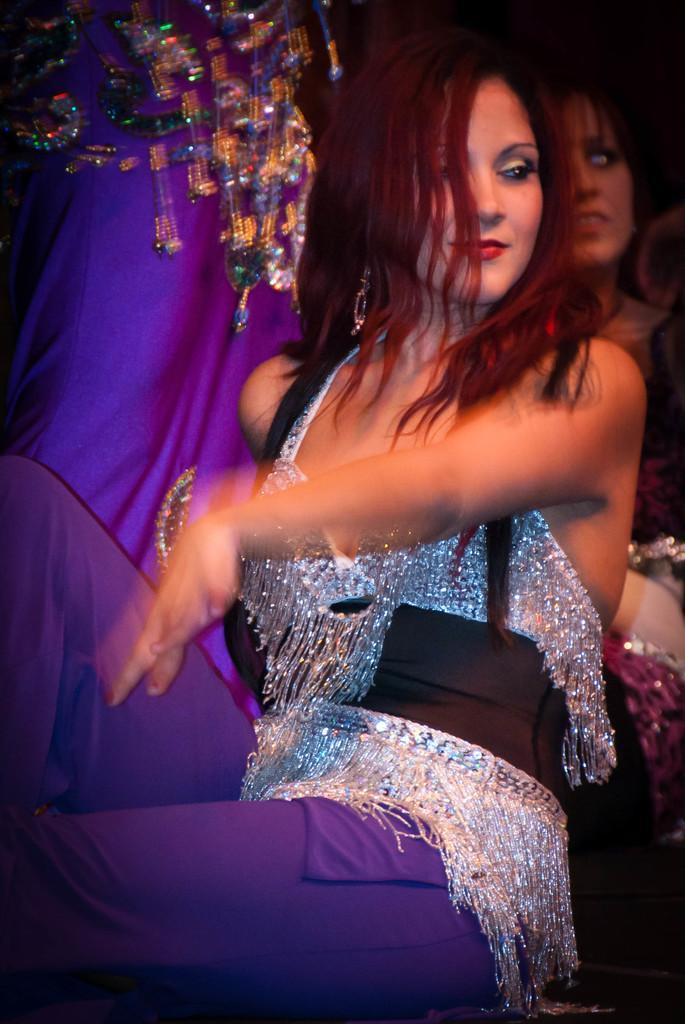Describe this image in one or two sentences. In the image we can see a woman wearing clothes, behind her there are other people. 